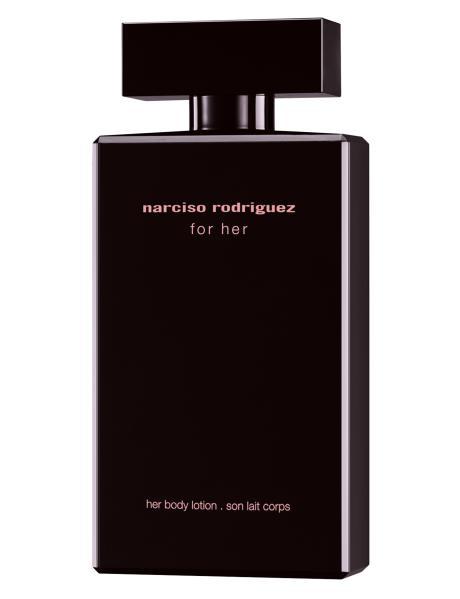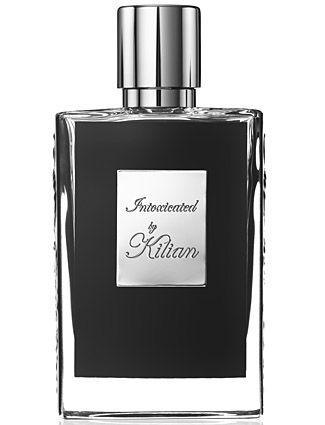The first image is the image on the left, the second image is the image on the right. Analyze the images presented: Is the assertion "One image features a black rectangular container with a flat black lid nearly as wide as the bottle." valid? Answer yes or no. Yes. The first image is the image on the left, the second image is the image on the right. Given the left and right images, does the statement "One square shaped bottle of men's cologne is shown in each of two images, one with a round cap and the other with a square cap." hold true? Answer yes or no. Yes. 